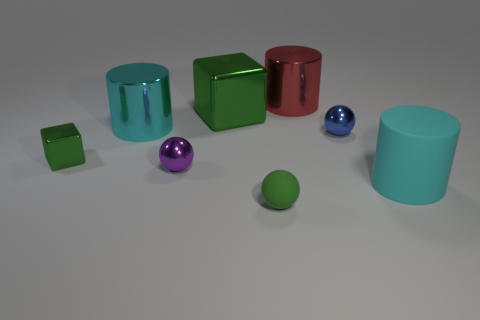Add 1 small green metal cubes. How many objects exist? 9 Subtract all spheres. How many objects are left? 5 Add 6 cyan metallic balls. How many cyan metallic balls exist? 6 Subtract 0 yellow cylinders. How many objects are left? 8 Subtract all large green rubber cylinders. Subtract all small green metal cubes. How many objects are left? 7 Add 2 small purple balls. How many small purple balls are left? 3 